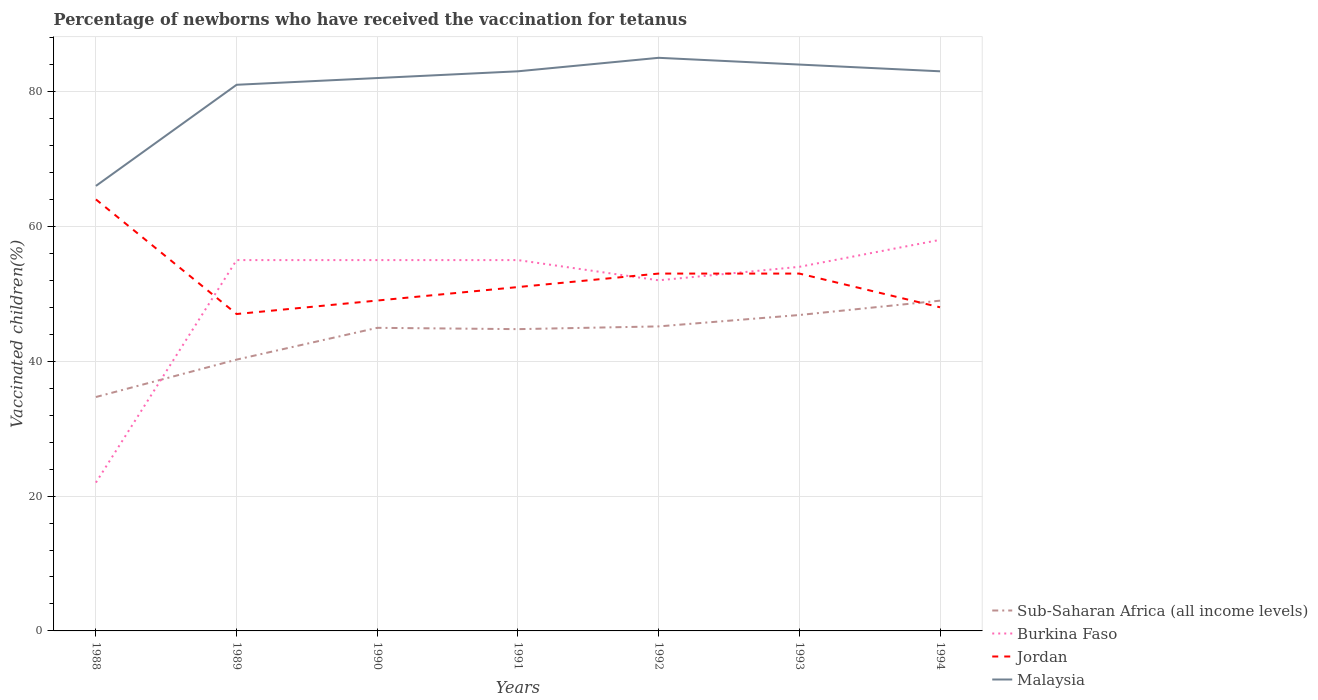Is the number of lines equal to the number of legend labels?
Make the answer very short. Yes. What is the total percentage of vaccinated children in Malaysia in the graph?
Offer a terse response. 1. What is the difference between the highest and the second highest percentage of vaccinated children in Malaysia?
Your answer should be very brief. 19. What is the difference between two consecutive major ticks on the Y-axis?
Provide a short and direct response. 20. What is the title of the graph?
Give a very brief answer. Percentage of newborns who have received the vaccination for tetanus. What is the label or title of the X-axis?
Offer a very short reply. Years. What is the label or title of the Y-axis?
Provide a short and direct response. Vaccinated children(%). What is the Vaccinated children(%) in Sub-Saharan Africa (all income levels) in 1988?
Make the answer very short. 34.69. What is the Vaccinated children(%) of Sub-Saharan Africa (all income levels) in 1989?
Make the answer very short. 40.24. What is the Vaccinated children(%) of Burkina Faso in 1989?
Provide a succinct answer. 55. What is the Vaccinated children(%) in Jordan in 1989?
Make the answer very short. 47. What is the Vaccinated children(%) of Sub-Saharan Africa (all income levels) in 1990?
Keep it short and to the point. 44.95. What is the Vaccinated children(%) in Burkina Faso in 1990?
Your answer should be very brief. 55. What is the Vaccinated children(%) of Jordan in 1990?
Provide a short and direct response. 49. What is the Vaccinated children(%) in Sub-Saharan Africa (all income levels) in 1991?
Your answer should be compact. 44.76. What is the Vaccinated children(%) of Malaysia in 1991?
Your response must be concise. 83. What is the Vaccinated children(%) in Sub-Saharan Africa (all income levels) in 1992?
Offer a very short reply. 45.17. What is the Vaccinated children(%) of Burkina Faso in 1992?
Give a very brief answer. 52. What is the Vaccinated children(%) in Malaysia in 1992?
Ensure brevity in your answer.  85. What is the Vaccinated children(%) of Sub-Saharan Africa (all income levels) in 1993?
Your answer should be compact. 46.85. What is the Vaccinated children(%) of Jordan in 1993?
Your answer should be very brief. 53. What is the Vaccinated children(%) of Sub-Saharan Africa (all income levels) in 1994?
Your answer should be very brief. 48.98. What is the Vaccinated children(%) in Jordan in 1994?
Your response must be concise. 48. What is the Vaccinated children(%) in Malaysia in 1994?
Ensure brevity in your answer.  83. Across all years, what is the maximum Vaccinated children(%) in Sub-Saharan Africa (all income levels)?
Your response must be concise. 48.98. Across all years, what is the maximum Vaccinated children(%) in Burkina Faso?
Offer a very short reply. 58. Across all years, what is the minimum Vaccinated children(%) in Sub-Saharan Africa (all income levels)?
Make the answer very short. 34.69. Across all years, what is the minimum Vaccinated children(%) in Burkina Faso?
Give a very brief answer. 22. What is the total Vaccinated children(%) in Sub-Saharan Africa (all income levels) in the graph?
Ensure brevity in your answer.  305.64. What is the total Vaccinated children(%) of Burkina Faso in the graph?
Your response must be concise. 351. What is the total Vaccinated children(%) in Jordan in the graph?
Give a very brief answer. 365. What is the total Vaccinated children(%) in Malaysia in the graph?
Offer a very short reply. 564. What is the difference between the Vaccinated children(%) of Sub-Saharan Africa (all income levels) in 1988 and that in 1989?
Keep it short and to the point. -5.55. What is the difference between the Vaccinated children(%) in Burkina Faso in 1988 and that in 1989?
Make the answer very short. -33. What is the difference between the Vaccinated children(%) of Sub-Saharan Africa (all income levels) in 1988 and that in 1990?
Your answer should be compact. -10.26. What is the difference between the Vaccinated children(%) of Burkina Faso in 1988 and that in 1990?
Your answer should be very brief. -33. What is the difference between the Vaccinated children(%) of Jordan in 1988 and that in 1990?
Keep it short and to the point. 15. What is the difference between the Vaccinated children(%) in Sub-Saharan Africa (all income levels) in 1988 and that in 1991?
Offer a very short reply. -10.07. What is the difference between the Vaccinated children(%) in Burkina Faso in 1988 and that in 1991?
Provide a succinct answer. -33. What is the difference between the Vaccinated children(%) of Jordan in 1988 and that in 1991?
Give a very brief answer. 13. What is the difference between the Vaccinated children(%) of Sub-Saharan Africa (all income levels) in 1988 and that in 1992?
Your answer should be compact. -10.47. What is the difference between the Vaccinated children(%) in Jordan in 1988 and that in 1992?
Your answer should be compact. 11. What is the difference between the Vaccinated children(%) of Sub-Saharan Africa (all income levels) in 1988 and that in 1993?
Make the answer very short. -12.16. What is the difference between the Vaccinated children(%) of Burkina Faso in 1988 and that in 1993?
Your answer should be compact. -32. What is the difference between the Vaccinated children(%) in Jordan in 1988 and that in 1993?
Your answer should be very brief. 11. What is the difference between the Vaccinated children(%) of Malaysia in 1988 and that in 1993?
Make the answer very short. -18. What is the difference between the Vaccinated children(%) of Sub-Saharan Africa (all income levels) in 1988 and that in 1994?
Provide a succinct answer. -14.29. What is the difference between the Vaccinated children(%) of Burkina Faso in 1988 and that in 1994?
Offer a very short reply. -36. What is the difference between the Vaccinated children(%) in Jordan in 1988 and that in 1994?
Your answer should be very brief. 16. What is the difference between the Vaccinated children(%) of Sub-Saharan Africa (all income levels) in 1989 and that in 1990?
Offer a terse response. -4.71. What is the difference between the Vaccinated children(%) in Burkina Faso in 1989 and that in 1990?
Your response must be concise. 0. What is the difference between the Vaccinated children(%) of Jordan in 1989 and that in 1990?
Give a very brief answer. -2. What is the difference between the Vaccinated children(%) of Malaysia in 1989 and that in 1990?
Provide a succinct answer. -1. What is the difference between the Vaccinated children(%) in Sub-Saharan Africa (all income levels) in 1989 and that in 1991?
Your answer should be compact. -4.52. What is the difference between the Vaccinated children(%) of Burkina Faso in 1989 and that in 1991?
Keep it short and to the point. 0. What is the difference between the Vaccinated children(%) of Sub-Saharan Africa (all income levels) in 1989 and that in 1992?
Keep it short and to the point. -4.93. What is the difference between the Vaccinated children(%) in Burkina Faso in 1989 and that in 1992?
Your answer should be compact. 3. What is the difference between the Vaccinated children(%) of Sub-Saharan Africa (all income levels) in 1989 and that in 1993?
Your answer should be compact. -6.62. What is the difference between the Vaccinated children(%) in Sub-Saharan Africa (all income levels) in 1989 and that in 1994?
Offer a very short reply. -8.74. What is the difference between the Vaccinated children(%) of Burkina Faso in 1989 and that in 1994?
Your response must be concise. -3. What is the difference between the Vaccinated children(%) in Jordan in 1989 and that in 1994?
Give a very brief answer. -1. What is the difference between the Vaccinated children(%) of Malaysia in 1989 and that in 1994?
Provide a succinct answer. -2. What is the difference between the Vaccinated children(%) of Sub-Saharan Africa (all income levels) in 1990 and that in 1991?
Offer a terse response. 0.2. What is the difference between the Vaccinated children(%) in Sub-Saharan Africa (all income levels) in 1990 and that in 1992?
Make the answer very short. -0.21. What is the difference between the Vaccinated children(%) of Sub-Saharan Africa (all income levels) in 1990 and that in 1993?
Provide a short and direct response. -1.9. What is the difference between the Vaccinated children(%) in Jordan in 1990 and that in 1993?
Provide a succinct answer. -4. What is the difference between the Vaccinated children(%) of Malaysia in 1990 and that in 1993?
Your answer should be compact. -2. What is the difference between the Vaccinated children(%) of Sub-Saharan Africa (all income levels) in 1990 and that in 1994?
Offer a terse response. -4.03. What is the difference between the Vaccinated children(%) in Burkina Faso in 1990 and that in 1994?
Provide a short and direct response. -3. What is the difference between the Vaccinated children(%) in Malaysia in 1990 and that in 1994?
Ensure brevity in your answer.  -1. What is the difference between the Vaccinated children(%) in Sub-Saharan Africa (all income levels) in 1991 and that in 1992?
Provide a short and direct response. -0.41. What is the difference between the Vaccinated children(%) of Jordan in 1991 and that in 1992?
Offer a terse response. -2. What is the difference between the Vaccinated children(%) in Sub-Saharan Africa (all income levels) in 1991 and that in 1993?
Your answer should be very brief. -2.1. What is the difference between the Vaccinated children(%) of Burkina Faso in 1991 and that in 1993?
Offer a terse response. 1. What is the difference between the Vaccinated children(%) in Sub-Saharan Africa (all income levels) in 1991 and that in 1994?
Offer a very short reply. -4.22. What is the difference between the Vaccinated children(%) of Burkina Faso in 1991 and that in 1994?
Your answer should be compact. -3. What is the difference between the Vaccinated children(%) in Jordan in 1991 and that in 1994?
Your answer should be compact. 3. What is the difference between the Vaccinated children(%) in Malaysia in 1991 and that in 1994?
Make the answer very short. 0. What is the difference between the Vaccinated children(%) of Sub-Saharan Africa (all income levels) in 1992 and that in 1993?
Offer a terse response. -1.69. What is the difference between the Vaccinated children(%) in Burkina Faso in 1992 and that in 1993?
Offer a very short reply. -2. What is the difference between the Vaccinated children(%) of Jordan in 1992 and that in 1993?
Your answer should be compact. 0. What is the difference between the Vaccinated children(%) of Malaysia in 1992 and that in 1993?
Your answer should be very brief. 1. What is the difference between the Vaccinated children(%) in Sub-Saharan Africa (all income levels) in 1992 and that in 1994?
Your answer should be compact. -3.82. What is the difference between the Vaccinated children(%) in Burkina Faso in 1992 and that in 1994?
Your answer should be compact. -6. What is the difference between the Vaccinated children(%) of Jordan in 1992 and that in 1994?
Ensure brevity in your answer.  5. What is the difference between the Vaccinated children(%) in Sub-Saharan Africa (all income levels) in 1993 and that in 1994?
Keep it short and to the point. -2.13. What is the difference between the Vaccinated children(%) of Jordan in 1993 and that in 1994?
Provide a short and direct response. 5. What is the difference between the Vaccinated children(%) of Malaysia in 1993 and that in 1994?
Provide a short and direct response. 1. What is the difference between the Vaccinated children(%) of Sub-Saharan Africa (all income levels) in 1988 and the Vaccinated children(%) of Burkina Faso in 1989?
Ensure brevity in your answer.  -20.31. What is the difference between the Vaccinated children(%) in Sub-Saharan Africa (all income levels) in 1988 and the Vaccinated children(%) in Jordan in 1989?
Provide a succinct answer. -12.31. What is the difference between the Vaccinated children(%) of Sub-Saharan Africa (all income levels) in 1988 and the Vaccinated children(%) of Malaysia in 1989?
Your answer should be very brief. -46.31. What is the difference between the Vaccinated children(%) of Burkina Faso in 1988 and the Vaccinated children(%) of Jordan in 1989?
Keep it short and to the point. -25. What is the difference between the Vaccinated children(%) of Burkina Faso in 1988 and the Vaccinated children(%) of Malaysia in 1989?
Provide a succinct answer. -59. What is the difference between the Vaccinated children(%) in Sub-Saharan Africa (all income levels) in 1988 and the Vaccinated children(%) in Burkina Faso in 1990?
Your response must be concise. -20.31. What is the difference between the Vaccinated children(%) of Sub-Saharan Africa (all income levels) in 1988 and the Vaccinated children(%) of Jordan in 1990?
Provide a succinct answer. -14.31. What is the difference between the Vaccinated children(%) in Sub-Saharan Africa (all income levels) in 1988 and the Vaccinated children(%) in Malaysia in 1990?
Your answer should be very brief. -47.31. What is the difference between the Vaccinated children(%) in Burkina Faso in 1988 and the Vaccinated children(%) in Jordan in 1990?
Keep it short and to the point. -27. What is the difference between the Vaccinated children(%) of Burkina Faso in 1988 and the Vaccinated children(%) of Malaysia in 1990?
Give a very brief answer. -60. What is the difference between the Vaccinated children(%) of Sub-Saharan Africa (all income levels) in 1988 and the Vaccinated children(%) of Burkina Faso in 1991?
Your answer should be compact. -20.31. What is the difference between the Vaccinated children(%) of Sub-Saharan Africa (all income levels) in 1988 and the Vaccinated children(%) of Jordan in 1991?
Your answer should be compact. -16.31. What is the difference between the Vaccinated children(%) of Sub-Saharan Africa (all income levels) in 1988 and the Vaccinated children(%) of Malaysia in 1991?
Your answer should be compact. -48.31. What is the difference between the Vaccinated children(%) of Burkina Faso in 1988 and the Vaccinated children(%) of Jordan in 1991?
Offer a very short reply. -29. What is the difference between the Vaccinated children(%) in Burkina Faso in 1988 and the Vaccinated children(%) in Malaysia in 1991?
Offer a very short reply. -61. What is the difference between the Vaccinated children(%) of Sub-Saharan Africa (all income levels) in 1988 and the Vaccinated children(%) of Burkina Faso in 1992?
Offer a terse response. -17.31. What is the difference between the Vaccinated children(%) in Sub-Saharan Africa (all income levels) in 1988 and the Vaccinated children(%) in Jordan in 1992?
Keep it short and to the point. -18.31. What is the difference between the Vaccinated children(%) in Sub-Saharan Africa (all income levels) in 1988 and the Vaccinated children(%) in Malaysia in 1992?
Make the answer very short. -50.31. What is the difference between the Vaccinated children(%) of Burkina Faso in 1988 and the Vaccinated children(%) of Jordan in 1992?
Ensure brevity in your answer.  -31. What is the difference between the Vaccinated children(%) of Burkina Faso in 1988 and the Vaccinated children(%) of Malaysia in 1992?
Ensure brevity in your answer.  -63. What is the difference between the Vaccinated children(%) in Sub-Saharan Africa (all income levels) in 1988 and the Vaccinated children(%) in Burkina Faso in 1993?
Give a very brief answer. -19.31. What is the difference between the Vaccinated children(%) of Sub-Saharan Africa (all income levels) in 1988 and the Vaccinated children(%) of Jordan in 1993?
Your answer should be compact. -18.31. What is the difference between the Vaccinated children(%) of Sub-Saharan Africa (all income levels) in 1988 and the Vaccinated children(%) of Malaysia in 1993?
Ensure brevity in your answer.  -49.31. What is the difference between the Vaccinated children(%) in Burkina Faso in 1988 and the Vaccinated children(%) in Jordan in 1993?
Provide a short and direct response. -31. What is the difference between the Vaccinated children(%) in Burkina Faso in 1988 and the Vaccinated children(%) in Malaysia in 1993?
Offer a very short reply. -62. What is the difference between the Vaccinated children(%) of Sub-Saharan Africa (all income levels) in 1988 and the Vaccinated children(%) of Burkina Faso in 1994?
Give a very brief answer. -23.31. What is the difference between the Vaccinated children(%) in Sub-Saharan Africa (all income levels) in 1988 and the Vaccinated children(%) in Jordan in 1994?
Offer a terse response. -13.31. What is the difference between the Vaccinated children(%) of Sub-Saharan Africa (all income levels) in 1988 and the Vaccinated children(%) of Malaysia in 1994?
Provide a short and direct response. -48.31. What is the difference between the Vaccinated children(%) in Burkina Faso in 1988 and the Vaccinated children(%) in Jordan in 1994?
Offer a terse response. -26. What is the difference between the Vaccinated children(%) in Burkina Faso in 1988 and the Vaccinated children(%) in Malaysia in 1994?
Your answer should be compact. -61. What is the difference between the Vaccinated children(%) of Jordan in 1988 and the Vaccinated children(%) of Malaysia in 1994?
Your answer should be compact. -19. What is the difference between the Vaccinated children(%) of Sub-Saharan Africa (all income levels) in 1989 and the Vaccinated children(%) of Burkina Faso in 1990?
Offer a very short reply. -14.76. What is the difference between the Vaccinated children(%) in Sub-Saharan Africa (all income levels) in 1989 and the Vaccinated children(%) in Jordan in 1990?
Your answer should be very brief. -8.76. What is the difference between the Vaccinated children(%) of Sub-Saharan Africa (all income levels) in 1989 and the Vaccinated children(%) of Malaysia in 1990?
Offer a terse response. -41.76. What is the difference between the Vaccinated children(%) of Burkina Faso in 1989 and the Vaccinated children(%) of Jordan in 1990?
Your response must be concise. 6. What is the difference between the Vaccinated children(%) of Burkina Faso in 1989 and the Vaccinated children(%) of Malaysia in 1990?
Make the answer very short. -27. What is the difference between the Vaccinated children(%) of Jordan in 1989 and the Vaccinated children(%) of Malaysia in 1990?
Keep it short and to the point. -35. What is the difference between the Vaccinated children(%) of Sub-Saharan Africa (all income levels) in 1989 and the Vaccinated children(%) of Burkina Faso in 1991?
Your answer should be very brief. -14.76. What is the difference between the Vaccinated children(%) of Sub-Saharan Africa (all income levels) in 1989 and the Vaccinated children(%) of Jordan in 1991?
Make the answer very short. -10.76. What is the difference between the Vaccinated children(%) of Sub-Saharan Africa (all income levels) in 1989 and the Vaccinated children(%) of Malaysia in 1991?
Your answer should be compact. -42.76. What is the difference between the Vaccinated children(%) of Burkina Faso in 1989 and the Vaccinated children(%) of Jordan in 1991?
Your response must be concise. 4. What is the difference between the Vaccinated children(%) in Burkina Faso in 1989 and the Vaccinated children(%) in Malaysia in 1991?
Your answer should be very brief. -28. What is the difference between the Vaccinated children(%) in Jordan in 1989 and the Vaccinated children(%) in Malaysia in 1991?
Keep it short and to the point. -36. What is the difference between the Vaccinated children(%) in Sub-Saharan Africa (all income levels) in 1989 and the Vaccinated children(%) in Burkina Faso in 1992?
Your response must be concise. -11.76. What is the difference between the Vaccinated children(%) of Sub-Saharan Africa (all income levels) in 1989 and the Vaccinated children(%) of Jordan in 1992?
Offer a terse response. -12.76. What is the difference between the Vaccinated children(%) of Sub-Saharan Africa (all income levels) in 1989 and the Vaccinated children(%) of Malaysia in 1992?
Offer a very short reply. -44.76. What is the difference between the Vaccinated children(%) in Burkina Faso in 1989 and the Vaccinated children(%) in Jordan in 1992?
Provide a short and direct response. 2. What is the difference between the Vaccinated children(%) in Jordan in 1989 and the Vaccinated children(%) in Malaysia in 1992?
Provide a short and direct response. -38. What is the difference between the Vaccinated children(%) in Sub-Saharan Africa (all income levels) in 1989 and the Vaccinated children(%) in Burkina Faso in 1993?
Your answer should be very brief. -13.76. What is the difference between the Vaccinated children(%) of Sub-Saharan Africa (all income levels) in 1989 and the Vaccinated children(%) of Jordan in 1993?
Your answer should be compact. -12.76. What is the difference between the Vaccinated children(%) of Sub-Saharan Africa (all income levels) in 1989 and the Vaccinated children(%) of Malaysia in 1993?
Offer a terse response. -43.76. What is the difference between the Vaccinated children(%) in Burkina Faso in 1989 and the Vaccinated children(%) in Jordan in 1993?
Offer a very short reply. 2. What is the difference between the Vaccinated children(%) in Burkina Faso in 1989 and the Vaccinated children(%) in Malaysia in 1993?
Offer a very short reply. -29. What is the difference between the Vaccinated children(%) of Jordan in 1989 and the Vaccinated children(%) of Malaysia in 1993?
Your response must be concise. -37. What is the difference between the Vaccinated children(%) in Sub-Saharan Africa (all income levels) in 1989 and the Vaccinated children(%) in Burkina Faso in 1994?
Provide a succinct answer. -17.76. What is the difference between the Vaccinated children(%) in Sub-Saharan Africa (all income levels) in 1989 and the Vaccinated children(%) in Jordan in 1994?
Offer a very short reply. -7.76. What is the difference between the Vaccinated children(%) of Sub-Saharan Africa (all income levels) in 1989 and the Vaccinated children(%) of Malaysia in 1994?
Make the answer very short. -42.76. What is the difference between the Vaccinated children(%) of Burkina Faso in 1989 and the Vaccinated children(%) of Malaysia in 1994?
Give a very brief answer. -28. What is the difference between the Vaccinated children(%) of Jordan in 1989 and the Vaccinated children(%) of Malaysia in 1994?
Your answer should be compact. -36. What is the difference between the Vaccinated children(%) in Sub-Saharan Africa (all income levels) in 1990 and the Vaccinated children(%) in Burkina Faso in 1991?
Make the answer very short. -10.05. What is the difference between the Vaccinated children(%) of Sub-Saharan Africa (all income levels) in 1990 and the Vaccinated children(%) of Jordan in 1991?
Make the answer very short. -6.05. What is the difference between the Vaccinated children(%) of Sub-Saharan Africa (all income levels) in 1990 and the Vaccinated children(%) of Malaysia in 1991?
Keep it short and to the point. -38.05. What is the difference between the Vaccinated children(%) in Burkina Faso in 1990 and the Vaccinated children(%) in Jordan in 1991?
Provide a succinct answer. 4. What is the difference between the Vaccinated children(%) in Jordan in 1990 and the Vaccinated children(%) in Malaysia in 1991?
Offer a terse response. -34. What is the difference between the Vaccinated children(%) of Sub-Saharan Africa (all income levels) in 1990 and the Vaccinated children(%) of Burkina Faso in 1992?
Your answer should be compact. -7.05. What is the difference between the Vaccinated children(%) of Sub-Saharan Africa (all income levels) in 1990 and the Vaccinated children(%) of Jordan in 1992?
Provide a succinct answer. -8.05. What is the difference between the Vaccinated children(%) in Sub-Saharan Africa (all income levels) in 1990 and the Vaccinated children(%) in Malaysia in 1992?
Your answer should be very brief. -40.05. What is the difference between the Vaccinated children(%) in Burkina Faso in 1990 and the Vaccinated children(%) in Malaysia in 1992?
Keep it short and to the point. -30. What is the difference between the Vaccinated children(%) in Jordan in 1990 and the Vaccinated children(%) in Malaysia in 1992?
Your answer should be very brief. -36. What is the difference between the Vaccinated children(%) of Sub-Saharan Africa (all income levels) in 1990 and the Vaccinated children(%) of Burkina Faso in 1993?
Make the answer very short. -9.05. What is the difference between the Vaccinated children(%) of Sub-Saharan Africa (all income levels) in 1990 and the Vaccinated children(%) of Jordan in 1993?
Your answer should be compact. -8.05. What is the difference between the Vaccinated children(%) in Sub-Saharan Africa (all income levels) in 1990 and the Vaccinated children(%) in Malaysia in 1993?
Ensure brevity in your answer.  -39.05. What is the difference between the Vaccinated children(%) of Burkina Faso in 1990 and the Vaccinated children(%) of Jordan in 1993?
Your answer should be very brief. 2. What is the difference between the Vaccinated children(%) in Jordan in 1990 and the Vaccinated children(%) in Malaysia in 1993?
Provide a short and direct response. -35. What is the difference between the Vaccinated children(%) of Sub-Saharan Africa (all income levels) in 1990 and the Vaccinated children(%) of Burkina Faso in 1994?
Ensure brevity in your answer.  -13.05. What is the difference between the Vaccinated children(%) of Sub-Saharan Africa (all income levels) in 1990 and the Vaccinated children(%) of Jordan in 1994?
Your answer should be very brief. -3.05. What is the difference between the Vaccinated children(%) of Sub-Saharan Africa (all income levels) in 1990 and the Vaccinated children(%) of Malaysia in 1994?
Offer a terse response. -38.05. What is the difference between the Vaccinated children(%) in Burkina Faso in 1990 and the Vaccinated children(%) in Malaysia in 1994?
Keep it short and to the point. -28. What is the difference between the Vaccinated children(%) of Jordan in 1990 and the Vaccinated children(%) of Malaysia in 1994?
Offer a terse response. -34. What is the difference between the Vaccinated children(%) of Sub-Saharan Africa (all income levels) in 1991 and the Vaccinated children(%) of Burkina Faso in 1992?
Keep it short and to the point. -7.24. What is the difference between the Vaccinated children(%) of Sub-Saharan Africa (all income levels) in 1991 and the Vaccinated children(%) of Jordan in 1992?
Your answer should be very brief. -8.24. What is the difference between the Vaccinated children(%) of Sub-Saharan Africa (all income levels) in 1991 and the Vaccinated children(%) of Malaysia in 1992?
Your response must be concise. -40.24. What is the difference between the Vaccinated children(%) of Jordan in 1991 and the Vaccinated children(%) of Malaysia in 1992?
Provide a succinct answer. -34. What is the difference between the Vaccinated children(%) of Sub-Saharan Africa (all income levels) in 1991 and the Vaccinated children(%) of Burkina Faso in 1993?
Your answer should be compact. -9.24. What is the difference between the Vaccinated children(%) in Sub-Saharan Africa (all income levels) in 1991 and the Vaccinated children(%) in Jordan in 1993?
Make the answer very short. -8.24. What is the difference between the Vaccinated children(%) in Sub-Saharan Africa (all income levels) in 1991 and the Vaccinated children(%) in Malaysia in 1993?
Give a very brief answer. -39.24. What is the difference between the Vaccinated children(%) of Burkina Faso in 1991 and the Vaccinated children(%) of Jordan in 1993?
Keep it short and to the point. 2. What is the difference between the Vaccinated children(%) of Burkina Faso in 1991 and the Vaccinated children(%) of Malaysia in 1993?
Provide a short and direct response. -29. What is the difference between the Vaccinated children(%) of Jordan in 1991 and the Vaccinated children(%) of Malaysia in 1993?
Your response must be concise. -33. What is the difference between the Vaccinated children(%) of Sub-Saharan Africa (all income levels) in 1991 and the Vaccinated children(%) of Burkina Faso in 1994?
Provide a succinct answer. -13.24. What is the difference between the Vaccinated children(%) in Sub-Saharan Africa (all income levels) in 1991 and the Vaccinated children(%) in Jordan in 1994?
Give a very brief answer. -3.24. What is the difference between the Vaccinated children(%) in Sub-Saharan Africa (all income levels) in 1991 and the Vaccinated children(%) in Malaysia in 1994?
Your response must be concise. -38.24. What is the difference between the Vaccinated children(%) in Burkina Faso in 1991 and the Vaccinated children(%) in Jordan in 1994?
Ensure brevity in your answer.  7. What is the difference between the Vaccinated children(%) in Jordan in 1991 and the Vaccinated children(%) in Malaysia in 1994?
Your response must be concise. -32. What is the difference between the Vaccinated children(%) in Sub-Saharan Africa (all income levels) in 1992 and the Vaccinated children(%) in Burkina Faso in 1993?
Provide a short and direct response. -8.83. What is the difference between the Vaccinated children(%) of Sub-Saharan Africa (all income levels) in 1992 and the Vaccinated children(%) of Jordan in 1993?
Offer a very short reply. -7.83. What is the difference between the Vaccinated children(%) in Sub-Saharan Africa (all income levels) in 1992 and the Vaccinated children(%) in Malaysia in 1993?
Offer a terse response. -38.83. What is the difference between the Vaccinated children(%) in Burkina Faso in 1992 and the Vaccinated children(%) in Jordan in 1993?
Give a very brief answer. -1. What is the difference between the Vaccinated children(%) of Burkina Faso in 1992 and the Vaccinated children(%) of Malaysia in 1993?
Make the answer very short. -32. What is the difference between the Vaccinated children(%) of Jordan in 1992 and the Vaccinated children(%) of Malaysia in 1993?
Keep it short and to the point. -31. What is the difference between the Vaccinated children(%) of Sub-Saharan Africa (all income levels) in 1992 and the Vaccinated children(%) of Burkina Faso in 1994?
Provide a succinct answer. -12.83. What is the difference between the Vaccinated children(%) of Sub-Saharan Africa (all income levels) in 1992 and the Vaccinated children(%) of Jordan in 1994?
Your answer should be very brief. -2.83. What is the difference between the Vaccinated children(%) in Sub-Saharan Africa (all income levels) in 1992 and the Vaccinated children(%) in Malaysia in 1994?
Offer a very short reply. -37.83. What is the difference between the Vaccinated children(%) in Burkina Faso in 1992 and the Vaccinated children(%) in Jordan in 1994?
Your response must be concise. 4. What is the difference between the Vaccinated children(%) of Burkina Faso in 1992 and the Vaccinated children(%) of Malaysia in 1994?
Keep it short and to the point. -31. What is the difference between the Vaccinated children(%) in Sub-Saharan Africa (all income levels) in 1993 and the Vaccinated children(%) in Burkina Faso in 1994?
Your answer should be very brief. -11.15. What is the difference between the Vaccinated children(%) in Sub-Saharan Africa (all income levels) in 1993 and the Vaccinated children(%) in Jordan in 1994?
Your answer should be compact. -1.15. What is the difference between the Vaccinated children(%) of Sub-Saharan Africa (all income levels) in 1993 and the Vaccinated children(%) of Malaysia in 1994?
Provide a succinct answer. -36.15. What is the average Vaccinated children(%) in Sub-Saharan Africa (all income levels) per year?
Provide a succinct answer. 43.66. What is the average Vaccinated children(%) of Burkina Faso per year?
Provide a short and direct response. 50.14. What is the average Vaccinated children(%) in Jordan per year?
Offer a terse response. 52.14. What is the average Vaccinated children(%) in Malaysia per year?
Provide a succinct answer. 80.57. In the year 1988, what is the difference between the Vaccinated children(%) of Sub-Saharan Africa (all income levels) and Vaccinated children(%) of Burkina Faso?
Your response must be concise. 12.69. In the year 1988, what is the difference between the Vaccinated children(%) of Sub-Saharan Africa (all income levels) and Vaccinated children(%) of Jordan?
Keep it short and to the point. -29.31. In the year 1988, what is the difference between the Vaccinated children(%) of Sub-Saharan Africa (all income levels) and Vaccinated children(%) of Malaysia?
Provide a succinct answer. -31.31. In the year 1988, what is the difference between the Vaccinated children(%) in Burkina Faso and Vaccinated children(%) in Jordan?
Your answer should be compact. -42. In the year 1988, what is the difference between the Vaccinated children(%) of Burkina Faso and Vaccinated children(%) of Malaysia?
Ensure brevity in your answer.  -44. In the year 1988, what is the difference between the Vaccinated children(%) of Jordan and Vaccinated children(%) of Malaysia?
Provide a short and direct response. -2. In the year 1989, what is the difference between the Vaccinated children(%) in Sub-Saharan Africa (all income levels) and Vaccinated children(%) in Burkina Faso?
Keep it short and to the point. -14.76. In the year 1989, what is the difference between the Vaccinated children(%) of Sub-Saharan Africa (all income levels) and Vaccinated children(%) of Jordan?
Your answer should be compact. -6.76. In the year 1989, what is the difference between the Vaccinated children(%) in Sub-Saharan Africa (all income levels) and Vaccinated children(%) in Malaysia?
Your answer should be very brief. -40.76. In the year 1989, what is the difference between the Vaccinated children(%) in Burkina Faso and Vaccinated children(%) in Jordan?
Ensure brevity in your answer.  8. In the year 1989, what is the difference between the Vaccinated children(%) in Jordan and Vaccinated children(%) in Malaysia?
Offer a terse response. -34. In the year 1990, what is the difference between the Vaccinated children(%) in Sub-Saharan Africa (all income levels) and Vaccinated children(%) in Burkina Faso?
Your answer should be very brief. -10.05. In the year 1990, what is the difference between the Vaccinated children(%) in Sub-Saharan Africa (all income levels) and Vaccinated children(%) in Jordan?
Your answer should be very brief. -4.05. In the year 1990, what is the difference between the Vaccinated children(%) of Sub-Saharan Africa (all income levels) and Vaccinated children(%) of Malaysia?
Keep it short and to the point. -37.05. In the year 1990, what is the difference between the Vaccinated children(%) in Burkina Faso and Vaccinated children(%) in Jordan?
Your answer should be very brief. 6. In the year 1990, what is the difference between the Vaccinated children(%) in Jordan and Vaccinated children(%) in Malaysia?
Make the answer very short. -33. In the year 1991, what is the difference between the Vaccinated children(%) of Sub-Saharan Africa (all income levels) and Vaccinated children(%) of Burkina Faso?
Your response must be concise. -10.24. In the year 1991, what is the difference between the Vaccinated children(%) in Sub-Saharan Africa (all income levels) and Vaccinated children(%) in Jordan?
Your answer should be compact. -6.24. In the year 1991, what is the difference between the Vaccinated children(%) of Sub-Saharan Africa (all income levels) and Vaccinated children(%) of Malaysia?
Keep it short and to the point. -38.24. In the year 1991, what is the difference between the Vaccinated children(%) of Burkina Faso and Vaccinated children(%) of Jordan?
Your answer should be very brief. 4. In the year 1991, what is the difference between the Vaccinated children(%) in Jordan and Vaccinated children(%) in Malaysia?
Your response must be concise. -32. In the year 1992, what is the difference between the Vaccinated children(%) of Sub-Saharan Africa (all income levels) and Vaccinated children(%) of Burkina Faso?
Offer a very short reply. -6.83. In the year 1992, what is the difference between the Vaccinated children(%) of Sub-Saharan Africa (all income levels) and Vaccinated children(%) of Jordan?
Provide a succinct answer. -7.83. In the year 1992, what is the difference between the Vaccinated children(%) of Sub-Saharan Africa (all income levels) and Vaccinated children(%) of Malaysia?
Make the answer very short. -39.83. In the year 1992, what is the difference between the Vaccinated children(%) in Burkina Faso and Vaccinated children(%) in Malaysia?
Provide a succinct answer. -33. In the year 1992, what is the difference between the Vaccinated children(%) of Jordan and Vaccinated children(%) of Malaysia?
Your response must be concise. -32. In the year 1993, what is the difference between the Vaccinated children(%) of Sub-Saharan Africa (all income levels) and Vaccinated children(%) of Burkina Faso?
Make the answer very short. -7.15. In the year 1993, what is the difference between the Vaccinated children(%) in Sub-Saharan Africa (all income levels) and Vaccinated children(%) in Jordan?
Provide a succinct answer. -6.15. In the year 1993, what is the difference between the Vaccinated children(%) in Sub-Saharan Africa (all income levels) and Vaccinated children(%) in Malaysia?
Offer a very short reply. -37.15. In the year 1993, what is the difference between the Vaccinated children(%) in Burkina Faso and Vaccinated children(%) in Malaysia?
Give a very brief answer. -30. In the year 1993, what is the difference between the Vaccinated children(%) of Jordan and Vaccinated children(%) of Malaysia?
Offer a very short reply. -31. In the year 1994, what is the difference between the Vaccinated children(%) of Sub-Saharan Africa (all income levels) and Vaccinated children(%) of Burkina Faso?
Give a very brief answer. -9.02. In the year 1994, what is the difference between the Vaccinated children(%) of Sub-Saharan Africa (all income levels) and Vaccinated children(%) of Jordan?
Provide a succinct answer. 0.98. In the year 1994, what is the difference between the Vaccinated children(%) of Sub-Saharan Africa (all income levels) and Vaccinated children(%) of Malaysia?
Provide a succinct answer. -34.02. In the year 1994, what is the difference between the Vaccinated children(%) in Burkina Faso and Vaccinated children(%) in Jordan?
Your answer should be compact. 10. In the year 1994, what is the difference between the Vaccinated children(%) of Burkina Faso and Vaccinated children(%) of Malaysia?
Give a very brief answer. -25. In the year 1994, what is the difference between the Vaccinated children(%) in Jordan and Vaccinated children(%) in Malaysia?
Keep it short and to the point. -35. What is the ratio of the Vaccinated children(%) in Sub-Saharan Africa (all income levels) in 1988 to that in 1989?
Your response must be concise. 0.86. What is the ratio of the Vaccinated children(%) in Burkina Faso in 1988 to that in 1989?
Provide a short and direct response. 0.4. What is the ratio of the Vaccinated children(%) of Jordan in 1988 to that in 1989?
Offer a terse response. 1.36. What is the ratio of the Vaccinated children(%) of Malaysia in 1988 to that in 1989?
Keep it short and to the point. 0.81. What is the ratio of the Vaccinated children(%) in Sub-Saharan Africa (all income levels) in 1988 to that in 1990?
Ensure brevity in your answer.  0.77. What is the ratio of the Vaccinated children(%) in Burkina Faso in 1988 to that in 1990?
Make the answer very short. 0.4. What is the ratio of the Vaccinated children(%) in Jordan in 1988 to that in 1990?
Provide a succinct answer. 1.31. What is the ratio of the Vaccinated children(%) in Malaysia in 1988 to that in 1990?
Offer a very short reply. 0.8. What is the ratio of the Vaccinated children(%) of Sub-Saharan Africa (all income levels) in 1988 to that in 1991?
Your answer should be compact. 0.78. What is the ratio of the Vaccinated children(%) in Burkina Faso in 1988 to that in 1991?
Ensure brevity in your answer.  0.4. What is the ratio of the Vaccinated children(%) in Jordan in 1988 to that in 1991?
Your response must be concise. 1.25. What is the ratio of the Vaccinated children(%) in Malaysia in 1988 to that in 1991?
Provide a succinct answer. 0.8. What is the ratio of the Vaccinated children(%) in Sub-Saharan Africa (all income levels) in 1988 to that in 1992?
Provide a short and direct response. 0.77. What is the ratio of the Vaccinated children(%) in Burkina Faso in 1988 to that in 1992?
Your answer should be compact. 0.42. What is the ratio of the Vaccinated children(%) in Jordan in 1988 to that in 1992?
Give a very brief answer. 1.21. What is the ratio of the Vaccinated children(%) of Malaysia in 1988 to that in 1992?
Keep it short and to the point. 0.78. What is the ratio of the Vaccinated children(%) of Sub-Saharan Africa (all income levels) in 1988 to that in 1993?
Offer a very short reply. 0.74. What is the ratio of the Vaccinated children(%) of Burkina Faso in 1988 to that in 1993?
Your answer should be very brief. 0.41. What is the ratio of the Vaccinated children(%) in Jordan in 1988 to that in 1993?
Your answer should be compact. 1.21. What is the ratio of the Vaccinated children(%) of Malaysia in 1988 to that in 1993?
Give a very brief answer. 0.79. What is the ratio of the Vaccinated children(%) of Sub-Saharan Africa (all income levels) in 1988 to that in 1994?
Offer a very short reply. 0.71. What is the ratio of the Vaccinated children(%) in Burkina Faso in 1988 to that in 1994?
Provide a short and direct response. 0.38. What is the ratio of the Vaccinated children(%) of Malaysia in 1988 to that in 1994?
Keep it short and to the point. 0.8. What is the ratio of the Vaccinated children(%) in Sub-Saharan Africa (all income levels) in 1989 to that in 1990?
Offer a terse response. 0.9. What is the ratio of the Vaccinated children(%) in Jordan in 1989 to that in 1990?
Make the answer very short. 0.96. What is the ratio of the Vaccinated children(%) of Sub-Saharan Africa (all income levels) in 1989 to that in 1991?
Give a very brief answer. 0.9. What is the ratio of the Vaccinated children(%) of Burkina Faso in 1989 to that in 1991?
Provide a succinct answer. 1. What is the ratio of the Vaccinated children(%) of Jordan in 1989 to that in 1991?
Make the answer very short. 0.92. What is the ratio of the Vaccinated children(%) in Malaysia in 1989 to that in 1991?
Your answer should be compact. 0.98. What is the ratio of the Vaccinated children(%) of Sub-Saharan Africa (all income levels) in 1989 to that in 1992?
Provide a short and direct response. 0.89. What is the ratio of the Vaccinated children(%) in Burkina Faso in 1989 to that in 1992?
Your answer should be compact. 1.06. What is the ratio of the Vaccinated children(%) in Jordan in 1989 to that in 1992?
Offer a terse response. 0.89. What is the ratio of the Vaccinated children(%) in Malaysia in 1989 to that in 1992?
Your answer should be compact. 0.95. What is the ratio of the Vaccinated children(%) in Sub-Saharan Africa (all income levels) in 1989 to that in 1993?
Your answer should be very brief. 0.86. What is the ratio of the Vaccinated children(%) of Burkina Faso in 1989 to that in 1993?
Offer a terse response. 1.02. What is the ratio of the Vaccinated children(%) of Jordan in 1989 to that in 1993?
Give a very brief answer. 0.89. What is the ratio of the Vaccinated children(%) of Malaysia in 1989 to that in 1993?
Keep it short and to the point. 0.96. What is the ratio of the Vaccinated children(%) in Sub-Saharan Africa (all income levels) in 1989 to that in 1994?
Provide a succinct answer. 0.82. What is the ratio of the Vaccinated children(%) in Burkina Faso in 1989 to that in 1994?
Provide a short and direct response. 0.95. What is the ratio of the Vaccinated children(%) in Jordan in 1989 to that in 1994?
Ensure brevity in your answer.  0.98. What is the ratio of the Vaccinated children(%) of Malaysia in 1989 to that in 1994?
Your answer should be very brief. 0.98. What is the ratio of the Vaccinated children(%) in Burkina Faso in 1990 to that in 1991?
Your response must be concise. 1. What is the ratio of the Vaccinated children(%) of Jordan in 1990 to that in 1991?
Ensure brevity in your answer.  0.96. What is the ratio of the Vaccinated children(%) in Malaysia in 1990 to that in 1991?
Provide a short and direct response. 0.99. What is the ratio of the Vaccinated children(%) in Sub-Saharan Africa (all income levels) in 1990 to that in 1992?
Provide a short and direct response. 1. What is the ratio of the Vaccinated children(%) of Burkina Faso in 1990 to that in 1992?
Your answer should be compact. 1.06. What is the ratio of the Vaccinated children(%) of Jordan in 1990 to that in 1992?
Keep it short and to the point. 0.92. What is the ratio of the Vaccinated children(%) in Malaysia in 1990 to that in 1992?
Keep it short and to the point. 0.96. What is the ratio of the Vaccinated children(%) of Sub-Saharan Africa (all income levels) in 1990 to that in 1993?
Ensure brevity in your answer.  0.96. What is the ratio of the Vaccinated children(%) in Burkina Faso in 1990 to that in 1993?
Offer a terse response. 1.02. What is the ratio of the Vaccinated children(%) in Jordan in 1990 to that in 1993?
Your answer should be compact. 0.92. What is the ratio of the Vaccinated children(%) of Malaysia in 1990 to that in 1993?
Make the answer very short. 0.98. What is the ratio of the Vaccinated children(%) in Sub-Saharan Africa (all income levels) in 1990 to that in 1994?
Give a very brief answer. 0.92. What is the ratio of the Vaccinated children(%) of Burkina Faso in 1990 to that in 1994?
Your answer should be very brief. 0.95. What is the ratio of the Vaccinated children(%) of Jordan in 1990 to that in 1994?
Your response must be concise. 1.02. What is the ratio of the Vaccinated children(%) in Sub-Saharan Africa (all income levels) in 1991 to that in 1992?
Provide a short and direct response. 0.99. What is the ratio of the Vaccinated children(%) in Burkina Faso in 1991 to that in 1992?
Offer a very short reply. 1.06. What is the ratio of the Vaccinated children(%) of Jordan in 1991 to that in 1992?
Your response must be concise. 0.96. What is the ratio of the Vaccinated children(%) of Malaysia in 1991 to that in 1992?
Your answer should be very brief. 0.98. What is the ratio of the Vaccinated children(%) in Sub-Saharan Africa (all income levels) in 1991 to that in 1993?
Your answer should be very brief. 0.96. What is the ratio of the Vaccinated children(%) of Burkina Faso in 1991 to that in 1993?
Give a very brief answer. 1.02. What is the ratio of the Vaccinated children(%) of Jordan in 1991 to that in 1993?
Provide a short and direct response. 0.96. What is the ratio of the Vaccinated children(%) in Sub-Saharan Africa (all income levels) in 1991 to that in 1994?
Offer a terse response. 0.91. What is the ratio of the Vaccinated children(%) in Burkina Faso in 1991 to that in 1994?
Your response must be concise. 0.95. What is the ratio of the Vaccinated children(%) in Jordan in 1992 to that in 1993?
Give a very brief answer. 1. What is the ratio of the Vaccinated children(%) of Malaysia in 1992 to that in 1993?
Make the answer very short. 1.01. What is the ratio of the Vaccinated children(%) of Sub-Saharan Africa (all income levels) in 1992 to that in 1994?
Your response must be concise. 0.92. What is the ratio of the Vaccinated children(%) of Burkina Faso in 1992 to that in 1994?
Provide a short and direct response. 0.9. What is the ratio of the Vaccinated children(%) of Jordan in 1992 to that in 1994?
Ensure brevity in your answer.  1.1. What is the ratio of the Vaccinated children(%) of Malaysia in 1992 to that in 1994?
Keep it short and to the point. 1.02. What is the ratio of the Vaccinated children(%) of Sub-Saharan Africa (all income levels) in 1993 to that in 1994?
Give a very brief answer. 0.96. What is the ratio of the Vaccinated children(%) in Jordan in 1993 to that in 1994?
Ensure brevity in your answer.  1.1. What is the difference between the highest and the second highest Vaccinated children(%) in Sub-Saharan Africa (all income levels)?
Your answer should be very brief. 2.13. What is the difference between the highest and the second highest Vaccinated children(%) of Burkina Faso?
Keep it short and to the point. 3. What is the difference between the highest and the second highest Vaccinated children(%) of Malaysia?
Your answer should be compact. 1. What is the difference between the highest and the lowest Vaccinated children(%) of Sub-Saharan Africa (all income levels)?
Your answer should be very brief. 14.29. What is the difference between the highest and the lowest Vaccinated children(%) in Burkina Faso?
Your response must be concise. 36. What is the difference between the highest and the lowest Vaccinated children(%) of Jordan?
Offer a terse response. 17. What is the difference between the highest and the lowest Vaccinated children(%) of Malaysia?
Offer a very short reply. 19. 